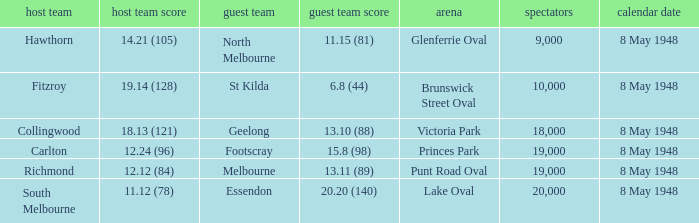Could you parse the entire table as a dict? {'header': ['host team', 'host team score', 'guest team', 'guest team score', 'arena', 'spectators', 'calendar date'], 'rows': [['Hawthorn', '14.21 (105)', 'North Melbourne', '11.15 (81)', 'Glenferrie Oval', '9,000', '8 May 1948'], ['Fitzroy', '19.14 (128)', 'St Kilda', '6.8 (44)', 'Brunswick Street Oval', '10,000', '8 May 1948'], ['Collingwood', '18.13 (121)', 'Geelong', '13.10 (88)', 'Victoria Park', '18,000', '8 May 1948'], ['Carlton', '12.24 (96)', 'Footscray', '15.8 (98)', 'Princes Park', '19,000', '8 May 1948'], ['Richmond', '12.12 (84)', 'Melbourne', '13.11 (89)', 'Punt Road Oval', '19,000', '8 May 1948'], ['South Melbourne', '11.12 (78)', 'Essendon', '20.20 (140)', 'Lake Oval', '20,000', '8 May 1948']]} How many spectators were at the game when the away team scored 15.8 (98)? 19000.0. 